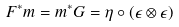<formula> <loc_0><loc_0><loc_500><loc_500>F ^ { * } m = m ^ { * } G = \eta \circ ( \epsilon \otimes \epsilon )</formula> 